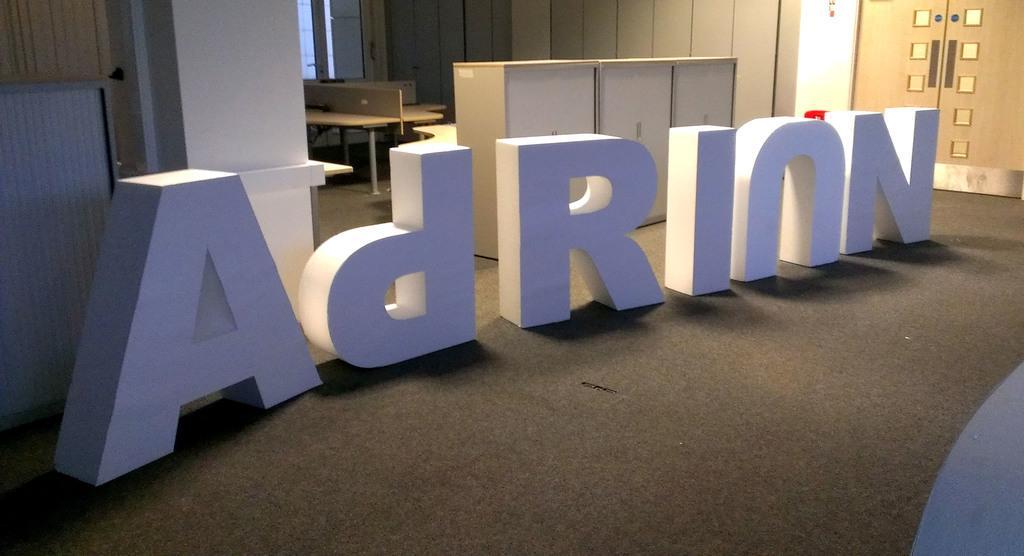Can you describe this image briefly? In this image there are letter blocks on the ground. In the background there are cupboards. On the right side top there is a door. In the background there is a window. Behind the blocks there's a wall. 